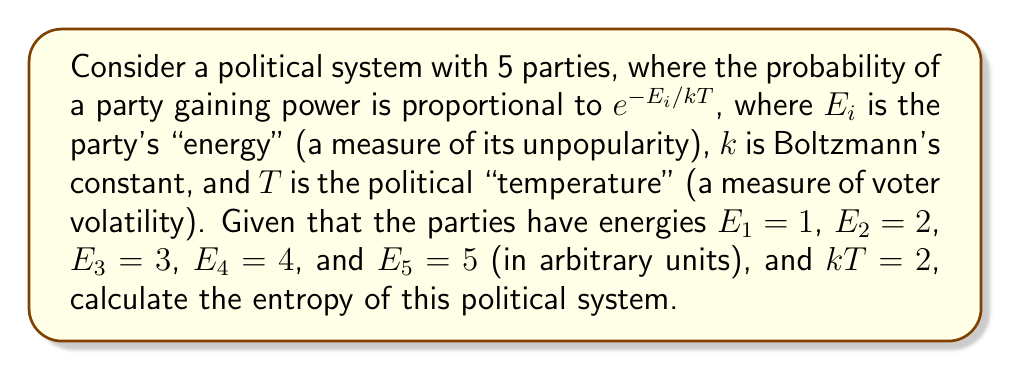Show me your answer to this math problem. To solve this problem, we'll follow these steps:

1) First, we need to calculate the probabilities of each party gaining power using the Boltzmann distribution:

   $p_i = \frac{e^{-E_i/kT}}{\sum_j e^{-E_j/kT}}$

2) Let's calculate the denominator (partition function) first:

   $Z = \sum_j e^{-E_j/kT} = e^{-1/2} + e^{-1} + e^{-3/2} + e^{-2} + e^{-5/2}$

3) Now we can calculate each probability:

   $p_1 = \frac{e^{-1/2}}{Z}$
   $p_2 = \frac{e^{-1}}{Z}$
   $p_3 = \frac{e^{-3/2}}{Z}$
   $p_4 = \frac{e^{-2}}{Z}$
   $p_5 = \frac{e^{-5/2}}{Z}$

4) The entropy of the system is given by:

   $S = -k\sum_i p_i \ln p_i$

5) Substituting the probabilities:

   $S = -k(\frac{e^{-1/2}}{Z} \ln \frac{e^{-1/2}}{Z} + \frac{e^{-1}}{Z} \ln \frac{e^{-1}}{Z} + \frac{e^{-3/2}}{Z} \ln \frac{e^{-3/2}}{Z} + \frac{e^{-2}}{Z} \ln \frac{e^{-2}}{Z} + \frac{e^{-5/2}}{Z} \ln \frac{e^{-5/2}}{Z})$

6) Simplify:

   $S = k(\ln Z + \frac{1}{2Z}e^{-1/2} + \frac{1}{Z}e^{-1} + \frac{3}{2Z}e^{-3/2} + \frac{2}{Z}e^{-2} + \frac{5}{2Z}e^{-5/2})$

7) Given that $kT = 2$, we can say $k = 2/T$. Substituting this:

   $S = \frac{2}{T}(\ln Z + \frac{1}{2Z}e^{-1/2} + \frac{1}{Z}e^{-1} + \frac{3}{2Z}e^{-3/2} + \frac{2}{Z}e^{-2} + \frac{5}{2Z}e^{-5/2})$

This is the final expression for the entropy of the political system.
Answer: $$S = \frac{2}{T}(\ln Z + \frac{1}{2Z}e^{-1/2} + \frac{1}{Z}e^{-1} + \frac{3}{2Z}e^{-3/2} + \frac{2}{Z}e^{-2} + \frac{5}{2Z}e^{-5/2})$$
where $Z = e^{-1/2} + e^{-1} + e^{-3/2} + e^{-2} + e^{-5/2}$ 